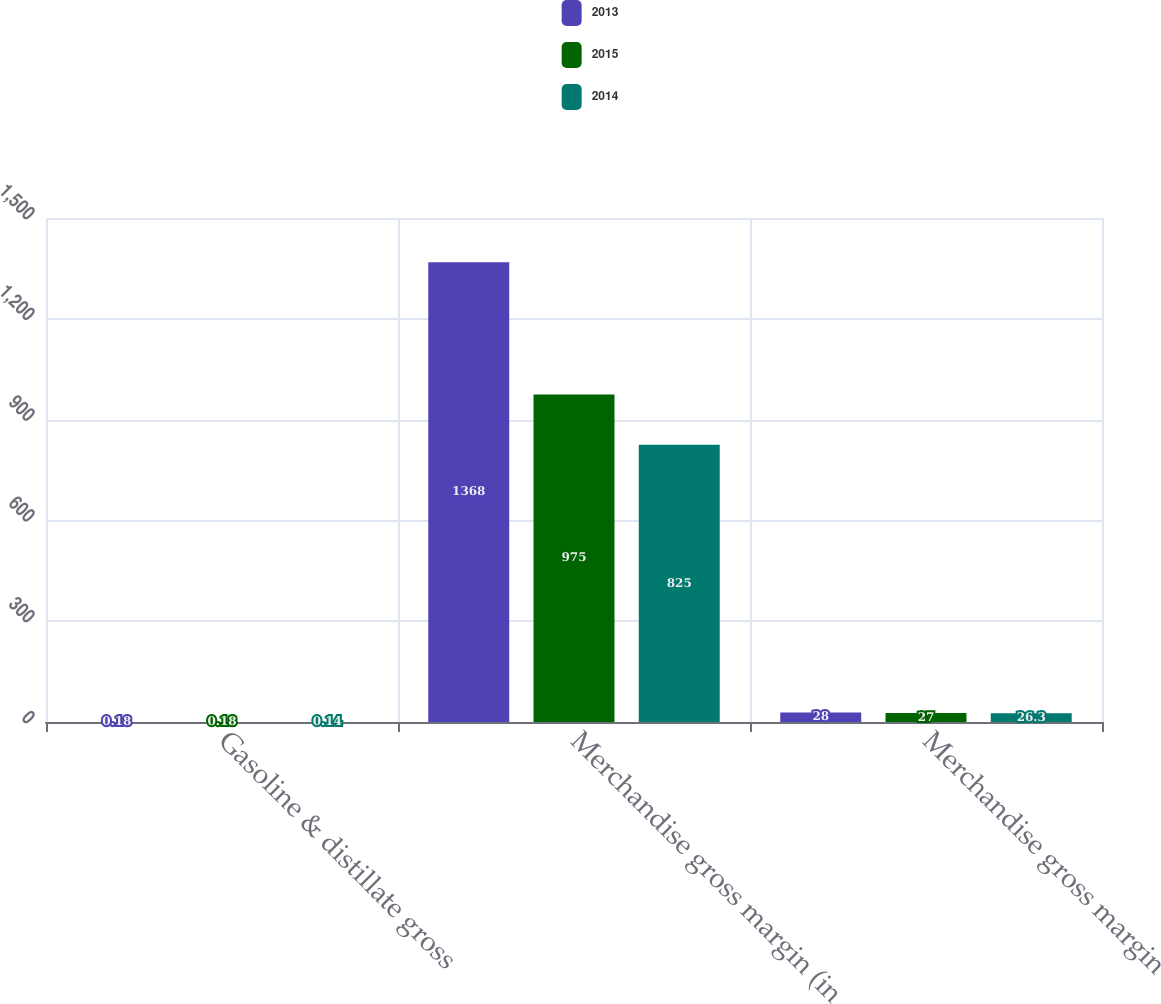Convert chart. <chart><loc_0><loc_0><loc_500><loc_500><stacked_bar_chart><ecel><fcel>Gasoline & distillate gross<fcel>Merchandise gross margin (in<fcel>Merchandise gross margin<nl><fcel>2013<fcel>0.18<fcel>1368<fcel>28<nl><fcel>2015<fcel>0.18<fcel>975<fcel>27<nl><fcel>2014<fcel>0.14<fcel>825<fcel>26.3<nl></chart> 